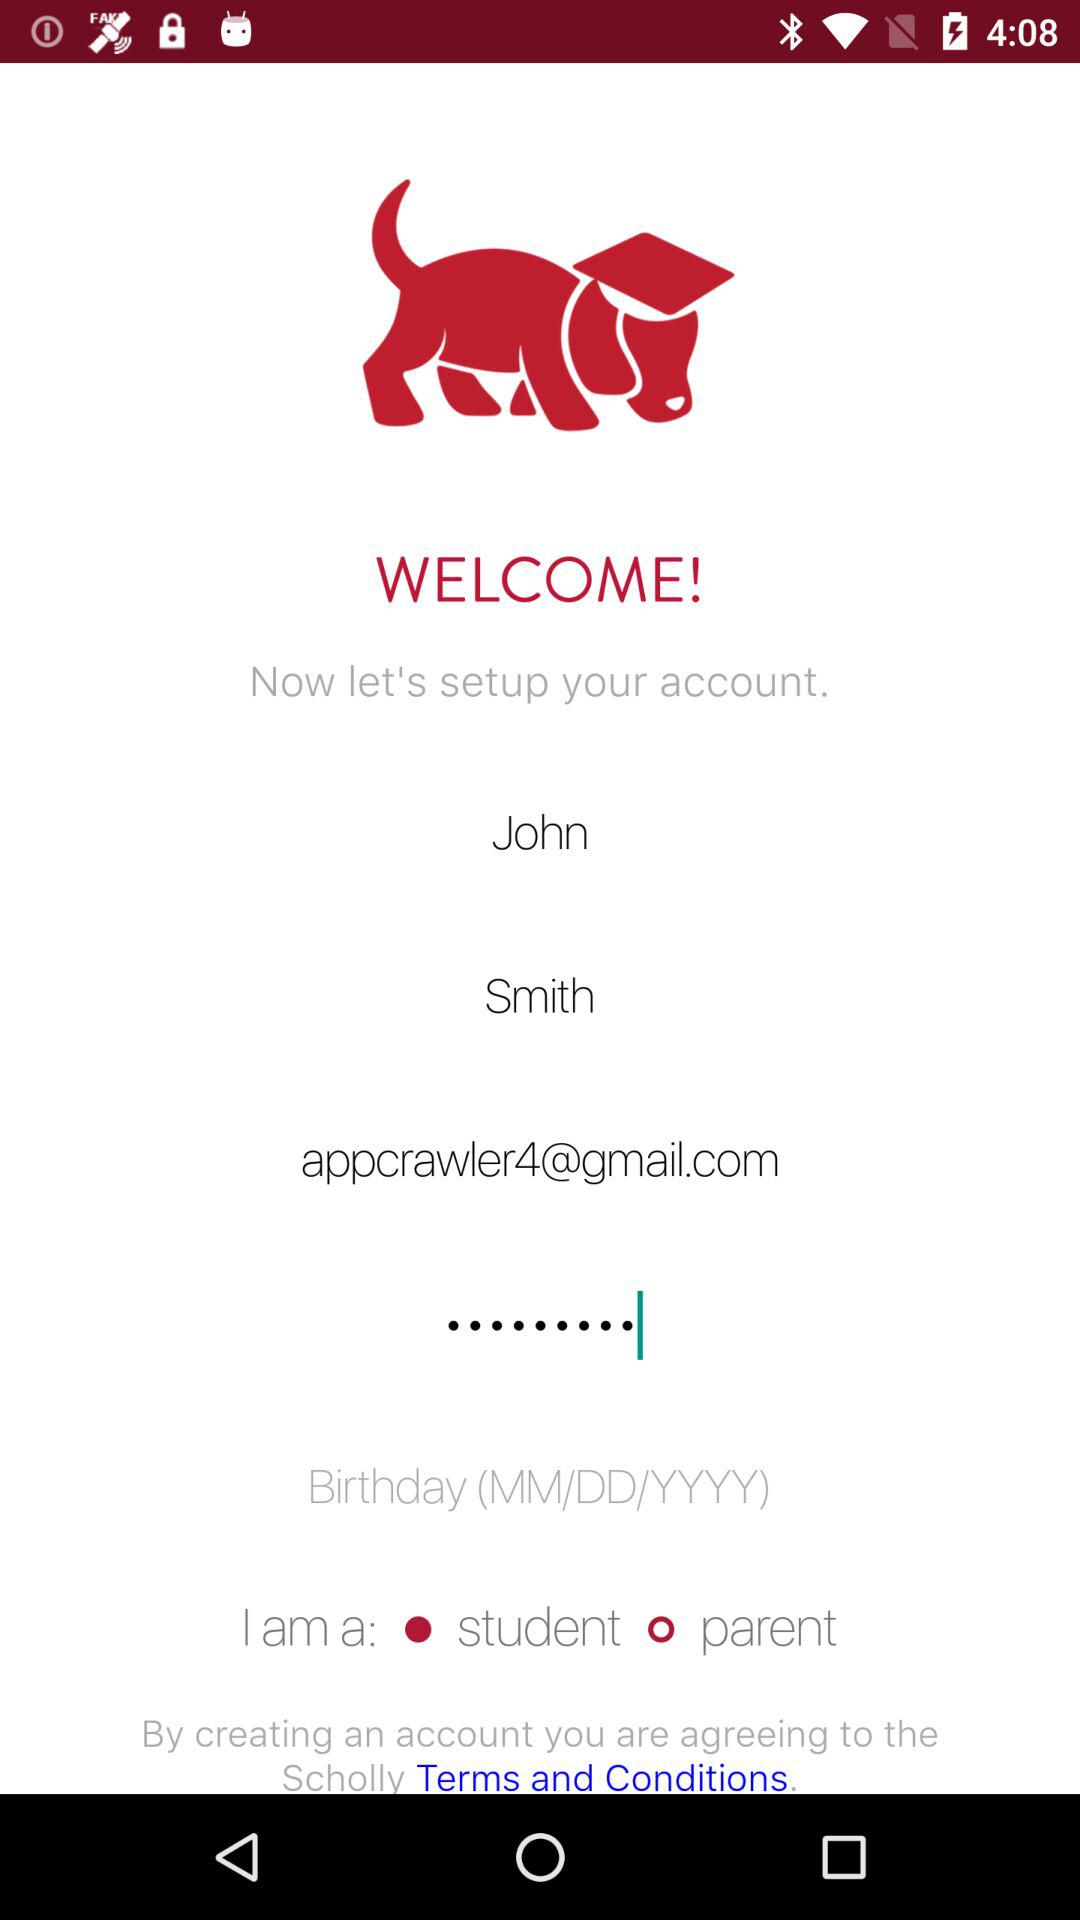What is the email address? The email address is appcrawler4@gmail.com. 